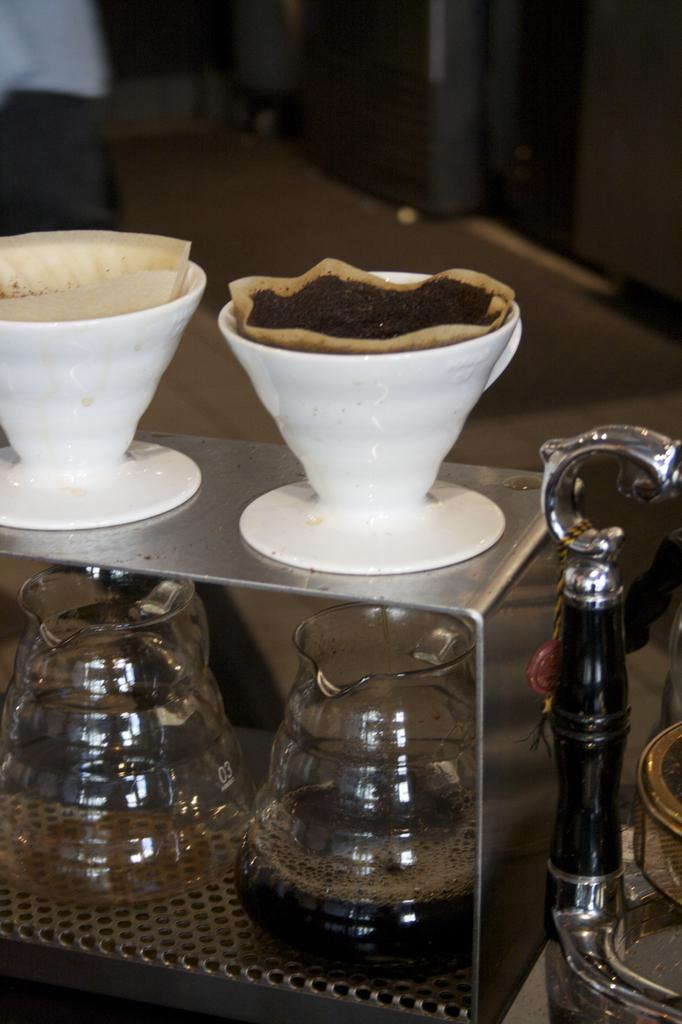What type of beverage containers are visible in the image? There are coffee cups and glasses in the image. Where are the coffee cups and glasses located? Both the coffee cups and glasses are on a table. What type of rat can be seen interacting with the coffee cups in the image? There is no rat present in the image; the coffee cups and glasses are on a table. What word is spoken by the glasses in the image? Glasses do not have the ability to speak or convey words, and there are no words present in the image. 